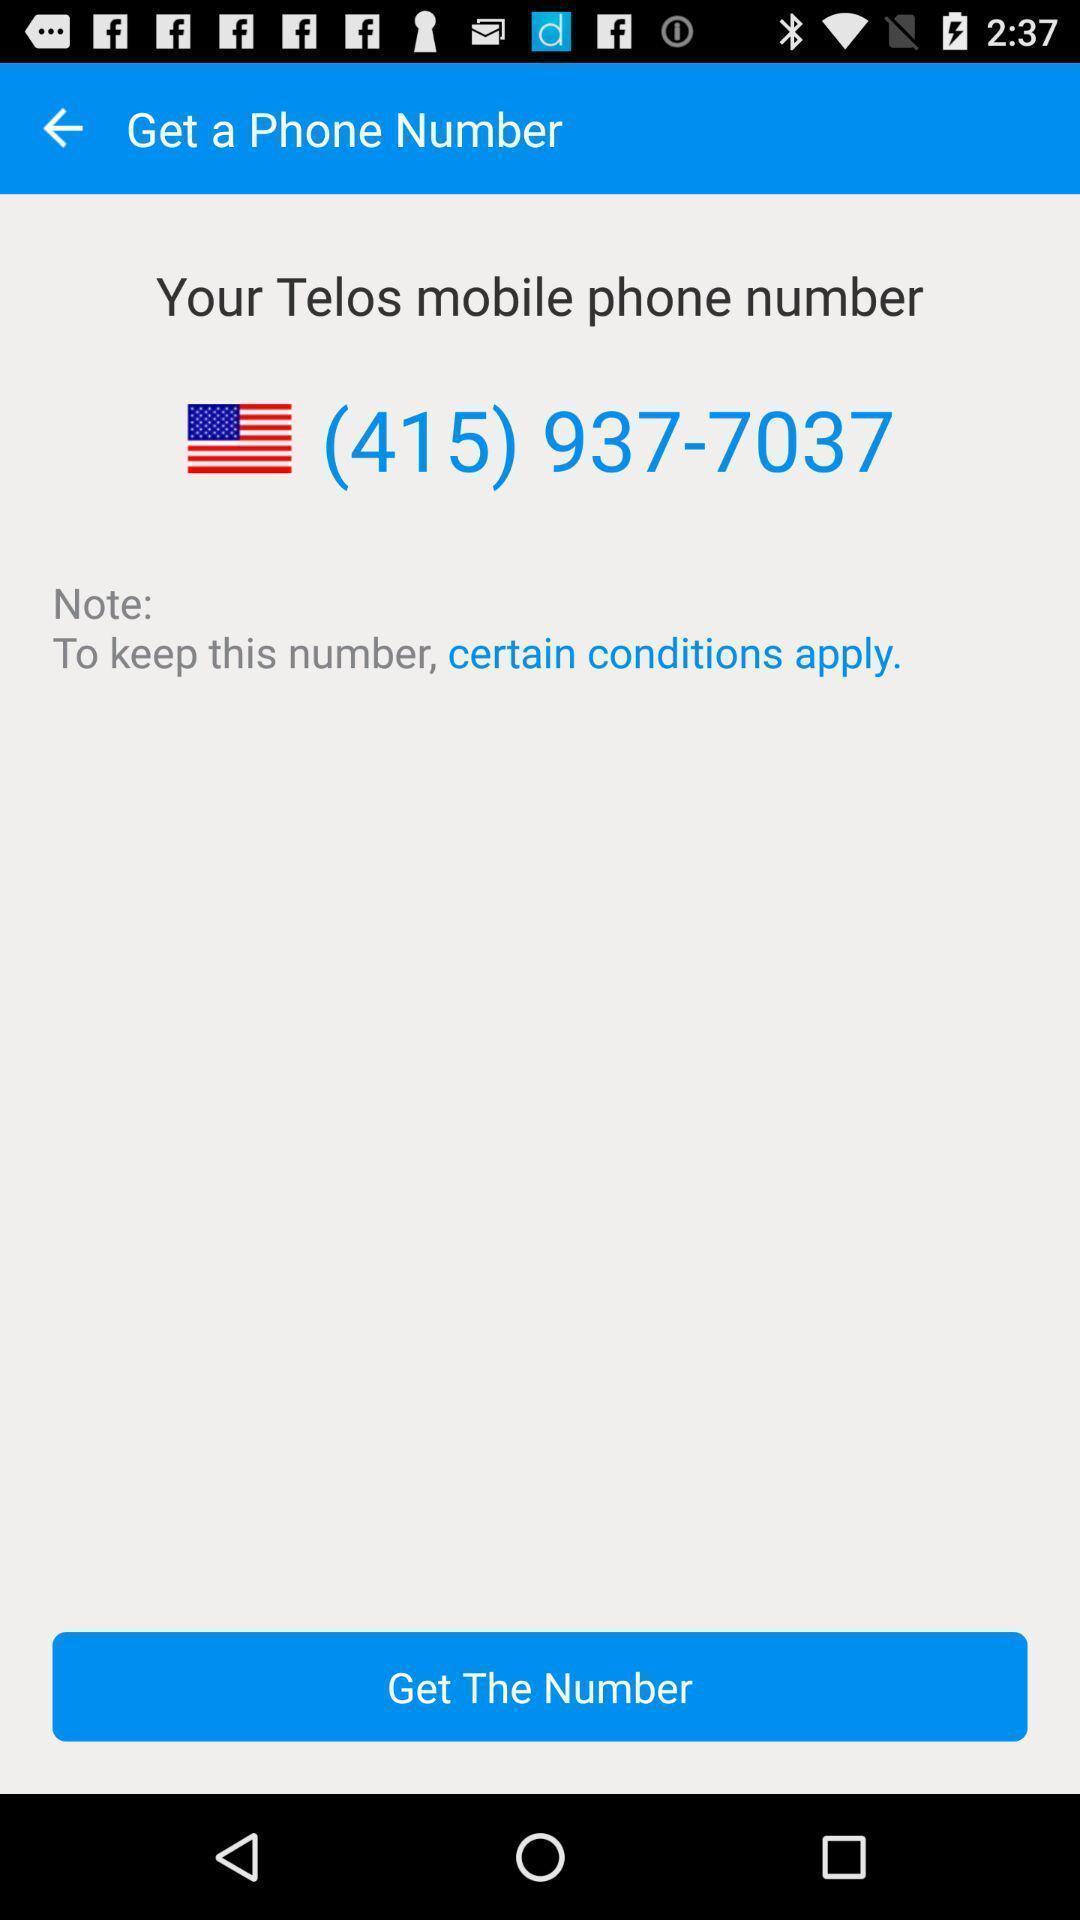Describe the visual elements of this screenshot. Showing get a phone number option in a call app. 